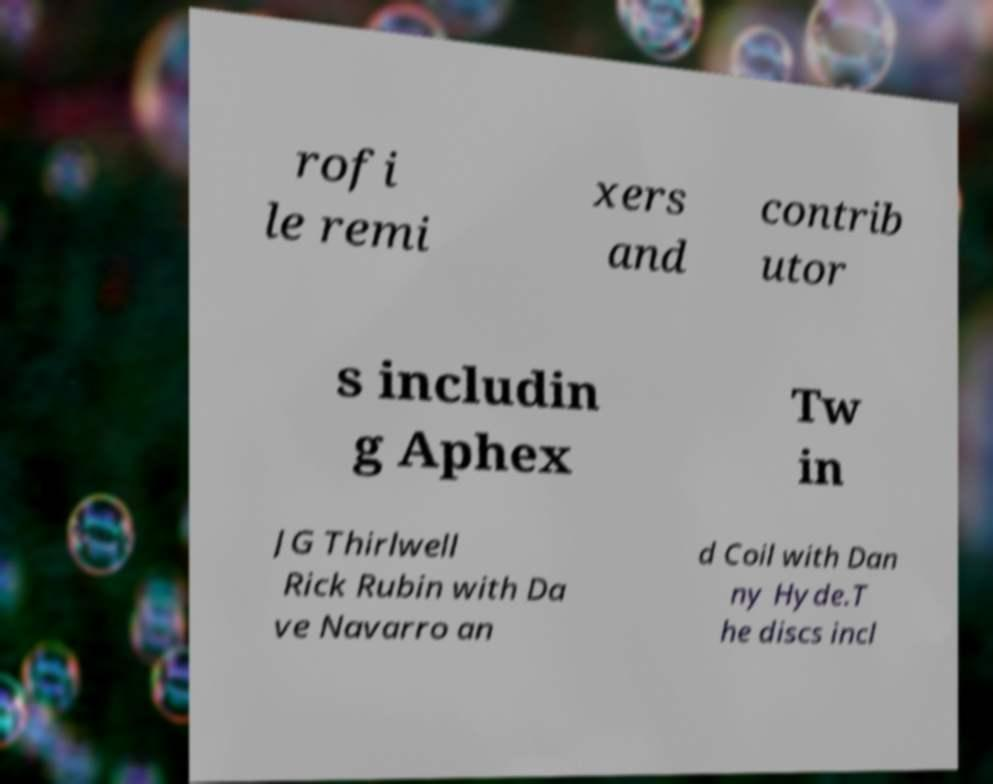Could you assist in decoding the text presented in this image and type it out clearly? rofi le remi xers and contrib utor s includin g Aphex Tw in JG Thirlwell Rick Rubin with Da ve Navarro an d Coil with Dan ny Hyde.T he discs incl 